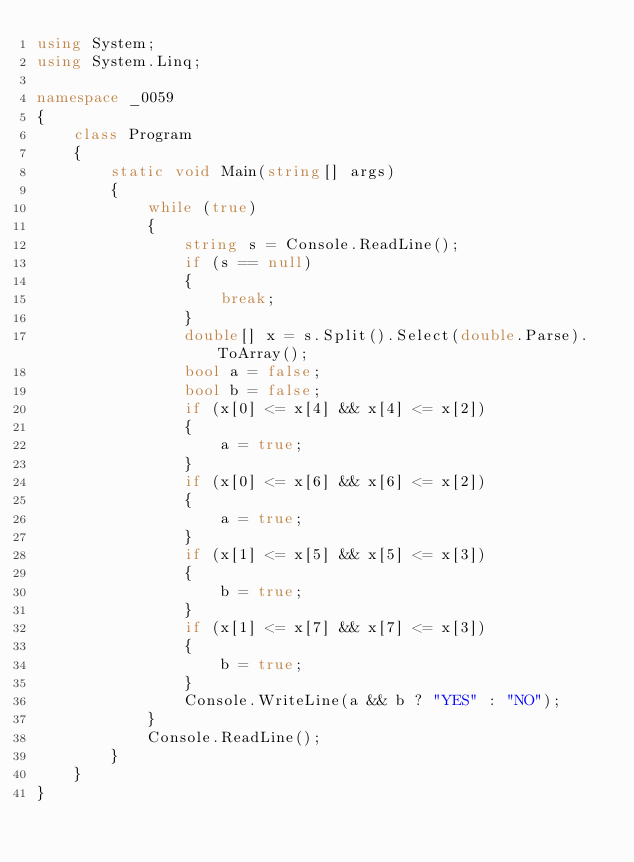Convert code to text. <code><loc_0><loc_0><loc_500><loc_500><_C#_>using System;
using System.Linq;

namespace _0059
{
    class Program
    {
        static void Main(string[] args)
        {
            while (true)
            {
                string s = Console.ReadLine();
                if (s == null)
                {
                    break;
                }
                double[] x = s.Split().Select(double.Parse).ToArray();
                bool a = false;
                bool b = false;
                if (x[0] <= x[4] && x[4] <= x[2])
                {
                    a = true;
                }
                if (x[0] <= x[6] && x[6] <= x[2])
                {
                    a = true;
                }
                if (x[1] <= x[5] && x[5] <= x[3])
                {
                    b = true;
                }
                if (x[1] <= x[7] && x[7] <= x[3])
                {
                    b = true;
                }
                Console.WriteLine(a && b ? "YES" : "NO");
            }
            Console.ReadLine();
        }
    }
}</code> 